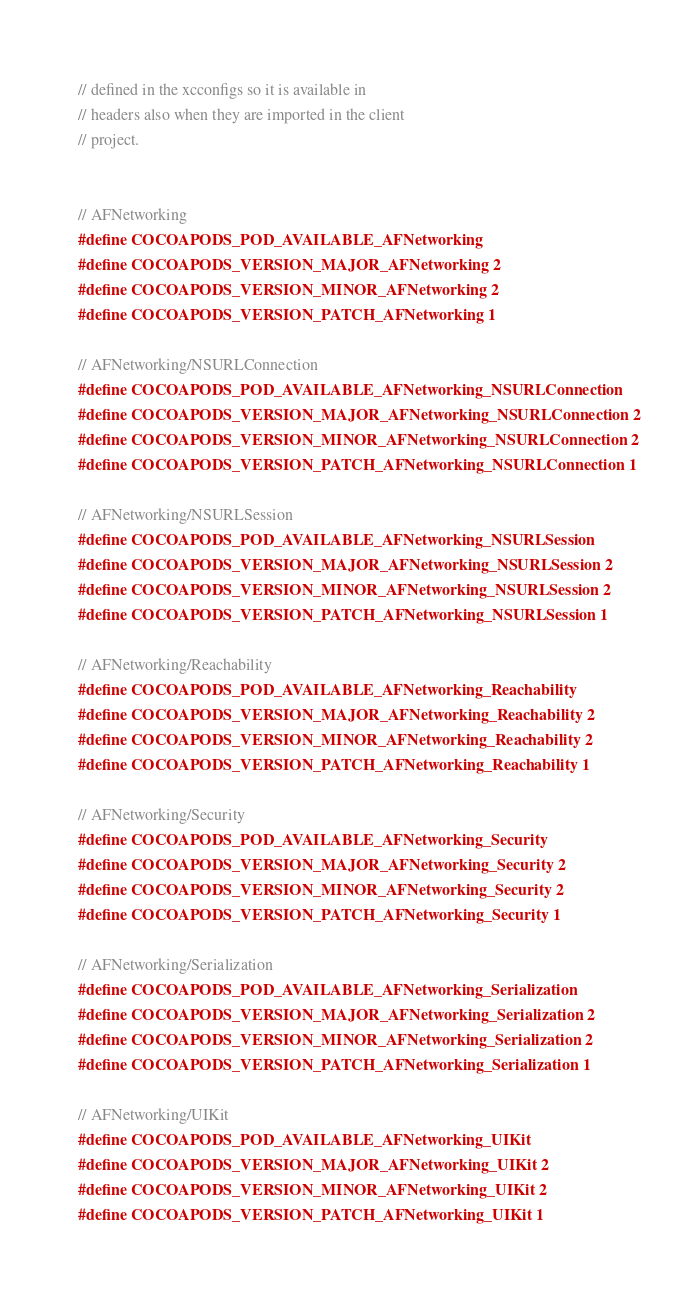<code> <loc_0><loc_0><loc_500><loc_500><_C_>// defined in the xcconfigs so it is available in
// headers also when they are imported in the client
// project.


// AFNetworking
#define COCOAPODS_POD_AVAILABLE_AFNetworking
#define COCOAPODS_VERSION_MAJOR_AFNetworking 2
#define COCOAPODS_VERSION_MINOR_AFNetworking 2
#define COCOAPODS_VERSION_PATCH_AFNetworking 1

// AFNetworking/NSURLConnection
#define COCOAPODS_POD_AVAILABLE_AFNetworking_NSURLConnection
#define COCOAPODS_VERSION_MAJOR_AFNetworking_NSURLConnection 2
#define COCOAPODS_VERSION_MINOR_AFNetworking_NSURLConnection 2
#define COCOAPODS_VERSION_PATCH_AFNetworking_NSURLConnection 1

// AFNetworking/NSURLSession
#define COCOAPODS_POD_AVAILABLE_AFNetworking_NSURLSession
#define COCOAPODS_VERSION_MAJOR_AFNetworking_NSURLSession 2
#define COCOAPODS_VERSION_MINOR_AFNetworking_NSURLSession 2
#define COCOAPODS_VERSION_PATCH_AFNetworking_NSURLSession 1

// AFNetworking/Reachability
#define COCOAPODS_POD_AVAILABLE_AFNetworking_Reachability
#define COCOAPODS_VERSION_MAJOR_AFNetworking_Reachability 2
#define COCOAPODS_VERSION_MINOR_AFNetworking_Reachability 2
#define COCOAPODS_VERSION_PATCH_AFNetworking_Reachability 1

// AFNetworking/Security
#define COCOAPODS_POD_AVAILABLE_AFNetworking_Security
#define COCOAPODS_VERSION_MAJOR_AFNetworking_Security 2
#define COCOAPODS_VERSION_MINOR_AFNetworking_Security 2
#define COCOAPODS_VERSION_PATCH_AFNetworking_Security 1

// AFNetworking/Serialization
#define COCOAPODS_POD_AVAILABLE_AFNetworking_Serialization
#define COCOAPODS_VERSION_MAJOR_AFNetworking_Serialization 2
#define COCOAPODS_VERSION_MINOR_AFNetworking_Serialization 2
#define COCOAPODS_VERSION_PATCH_AFNetworking_Serialization 1

// AFNetworking/UIKit
#define COCOAPODS_POD_AVAILABLE_AFNetworking_UIKit
#define COCOAPODS_VERSION_MAJOR_AFNetworking_UIKit 2
#define COCOAPODS_VERSION_MINOR_AFNetworking_UIKit 2
#define COCOAPODS_VERSION_PATCH_AFNetworking_UIKit 1

</code> 